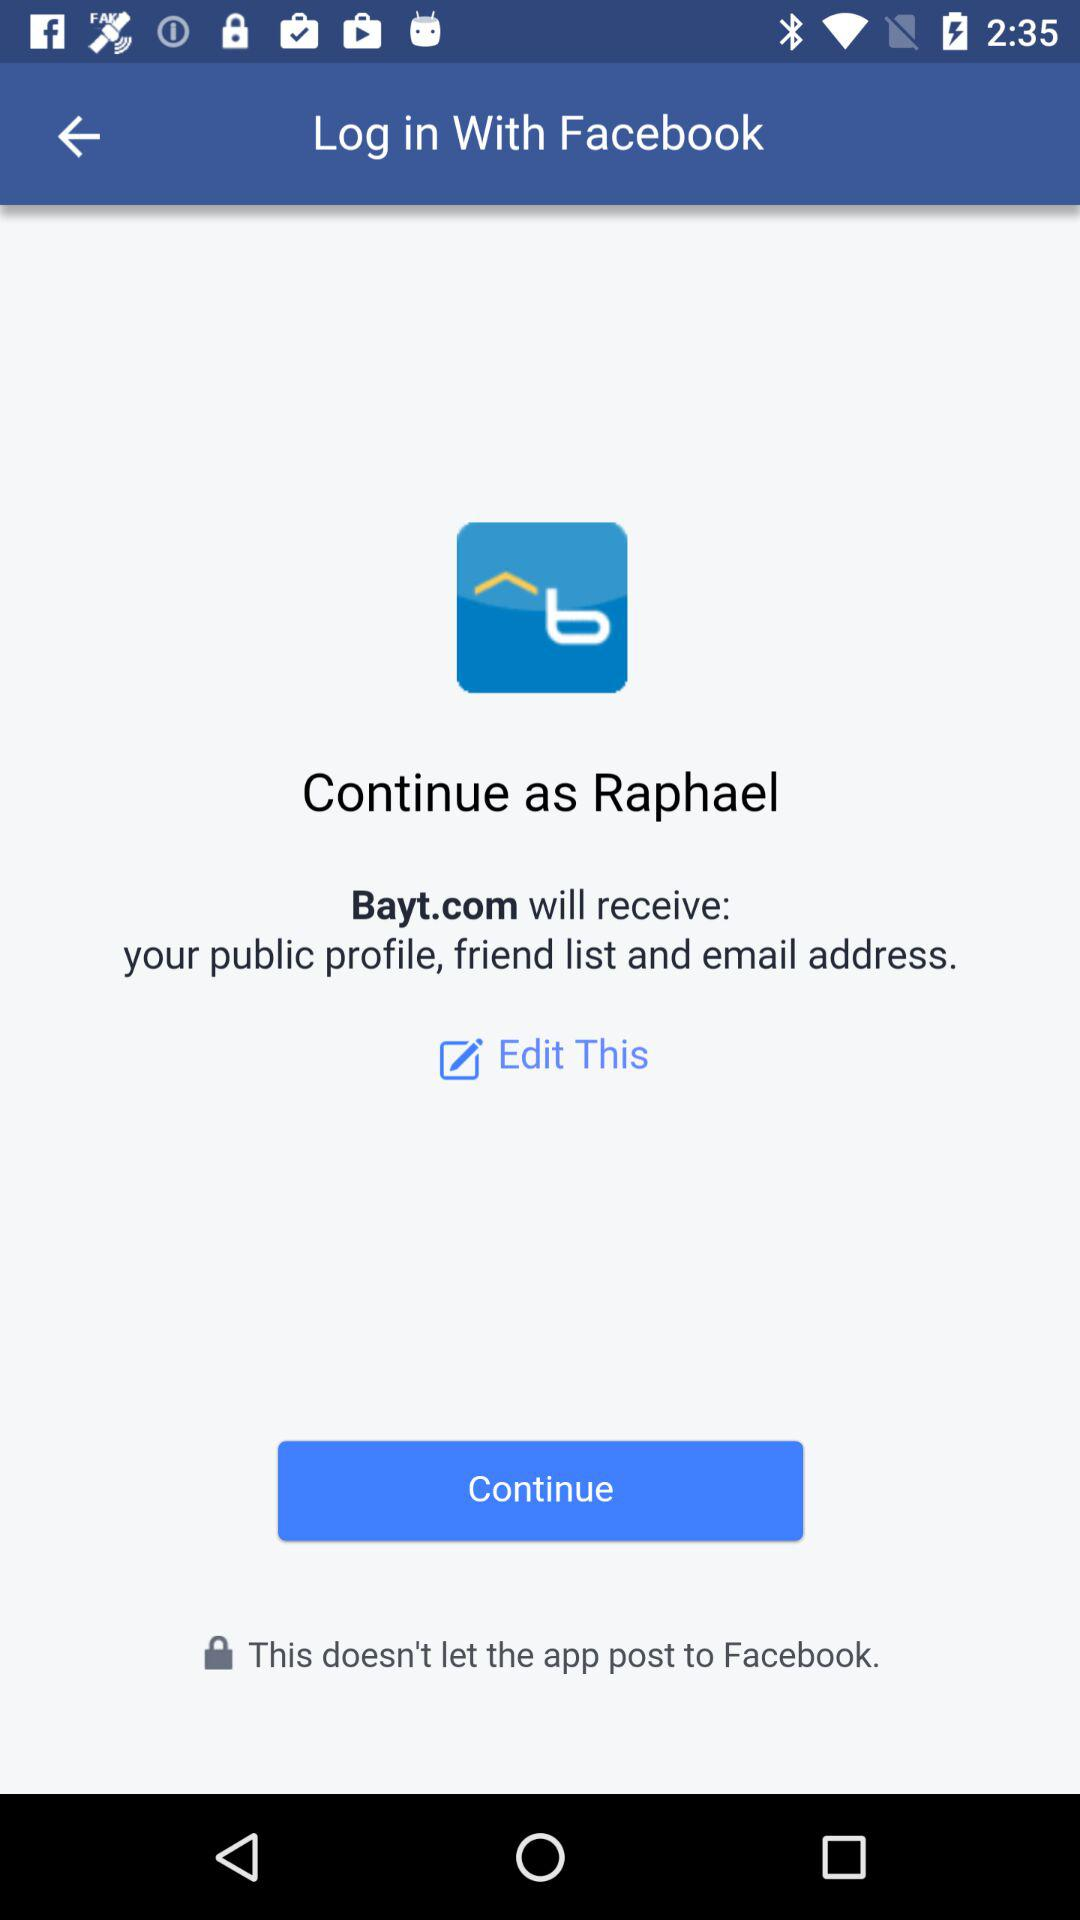What is the login name? The login name is Raphael. 